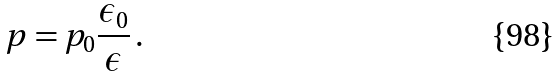Convert formula to latex. <formula><loc_0><loc_0><loc_500><loc_500>p = p _ { 0 } \frac { \epsilon _ { 0 } } { \epsilon } \, .</formula> 